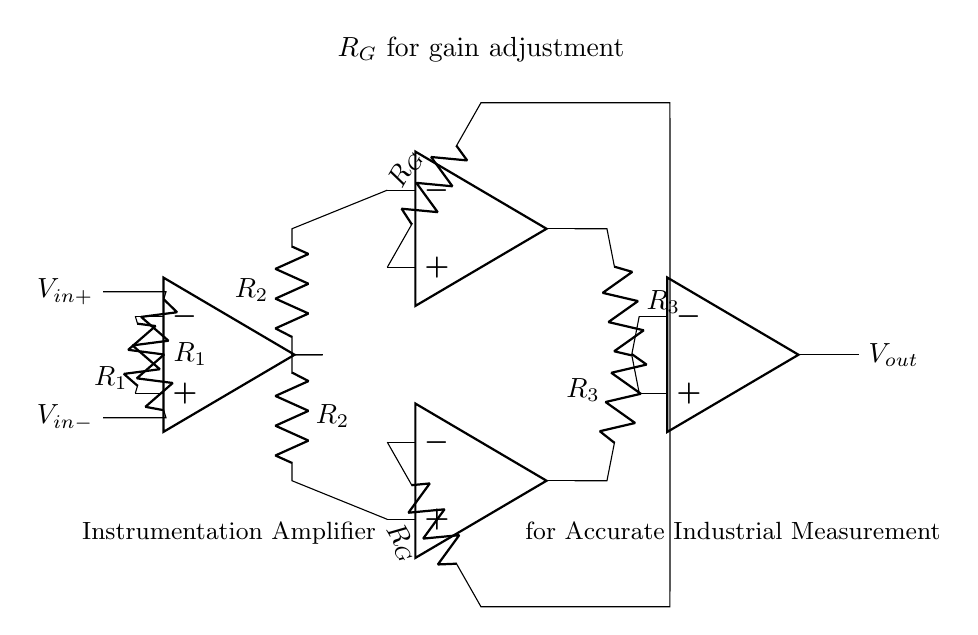What are the input voltages of the amplifier? The input voltages are labeled as V in+ and V in-. These are the voltages connected to the non-inverting and inverting inputs of the first operational amplifier, respectively.
Answer: V in+, V in- What is the function of R_G in this circuit? R_G is used for gain adjustment in the circuit. It is connected between the output of the first operational amplifier stages, allowing modifications to the overall amplification factor of the instrumentation amplifier.
Answer: Gain adjustment How many operational amplifiers are used in this circuit? The circuit includes four operational amplifiers, as indicated by the four op amp symbols drawn in the diagram.
Answer: Four What is the output voltage of the instrumentation amplifier labeled as? The output voltage is labeled as V out, which represents the amplified signal after processing the input voltages through the operational amplifier stages.
Answer: V out Why are there two feedback resistors labeled R_2 in this circuit? The two feedback resistors R_2 are used to create a balanced feedback path for the separate operational amplifiers configured in the instrumentation amplifier, helping to stabilize the gain and improve accuracy.
Answer: Stabilize gain If the resistors R_1 and R_2 are equal, what can be said about the gain of the amplifier? If R_1 and R_2 are equal, the gain of the amplifier is determined primarily by the resistor R_G, providing the formula for gain as a function of R_G and the other resistors. This simplifies analysis because equal resistors lead to a predictable gain relationship.
Answer: Function of R_G What is the primary application of this instrumentation amplifier? The primary application is for accurate measurement of industrial process variables, indicated in the label at the bottom of the circuit diagram. This suggests it is designed for precise conditions found in industrial environments.
Answer: Accurate measurement 